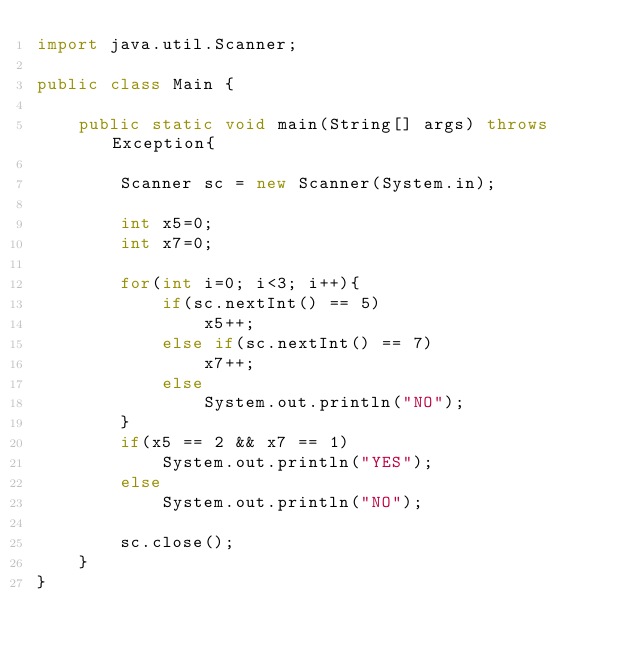Convert code to text. <code><loc_0><loc_0><loc_500><loc_500><_Java_>import java.util.Scanner;

public class Main {
	
	public static void main(String[] args) throws Exception{
		
		Scanner sc = new Scanner(System.in);
		
		int x5=0;
		int x7=0;
		
		for(int i=0; i<3; i++){
			if(sc.nextInt() == 5)
				x5++;
			else if(sc.nextInt() == 7)
				x7++;
			else
				System.out.println("NO");
		}
		if(x5 == 2 && x7 == 1)
			System.out.println("YES");
		else
			System.out.println("NO");
		
		sc.close();
	}
}
</code> 